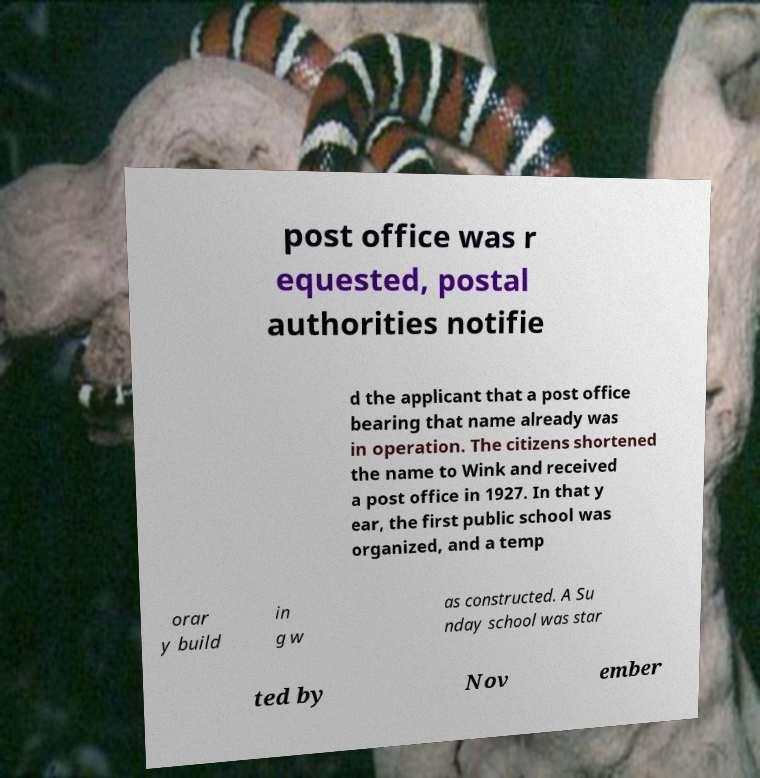Please identify and transcribe the text found in this image. post office was r equested, postal authorities notifie d the applicant that a post office bearing that name already was in operation. The citizens shortened the name to Wink and received a post office in 1927. In that y ear, the first public school was organized, and a temp orar y build in g w as constructed. A Su nday school was star ted by Nov ember 